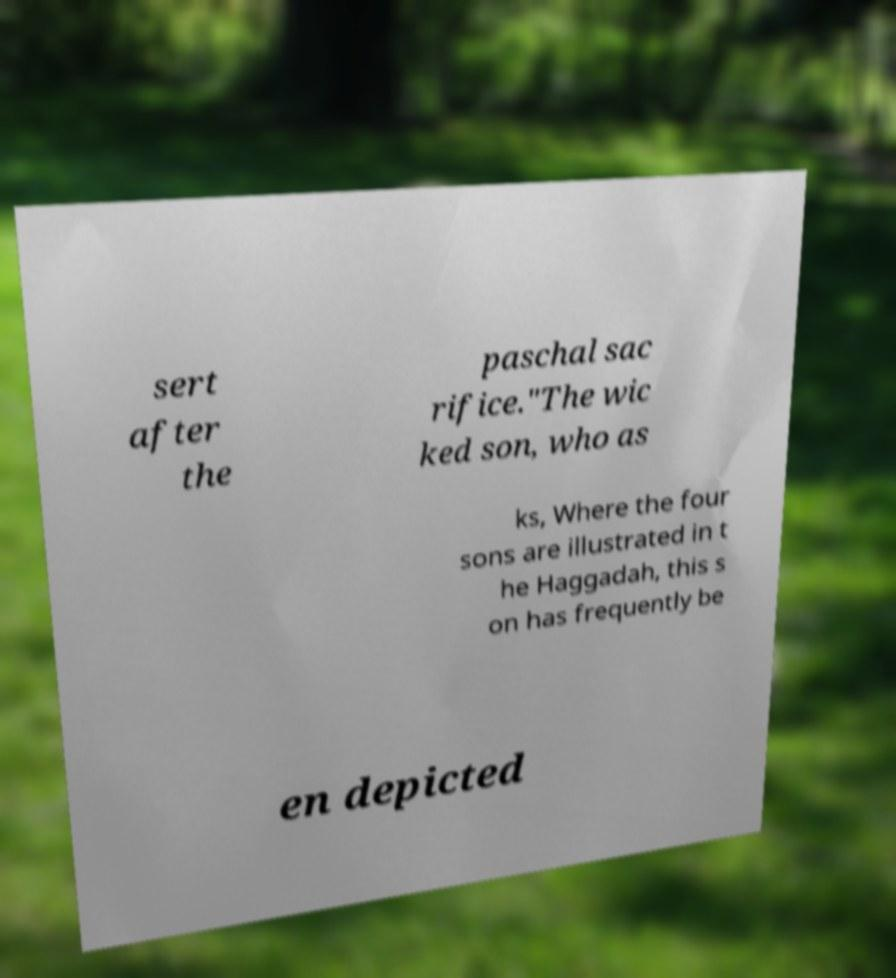There's text embedded in this image that I need extracted. Can you transcribe it verbatim? sert after the paschal sac rifice."The wic ked son, who as ks, Where the four sons are illustrated in t he Haggadah, this s on has frequently be en depicted 